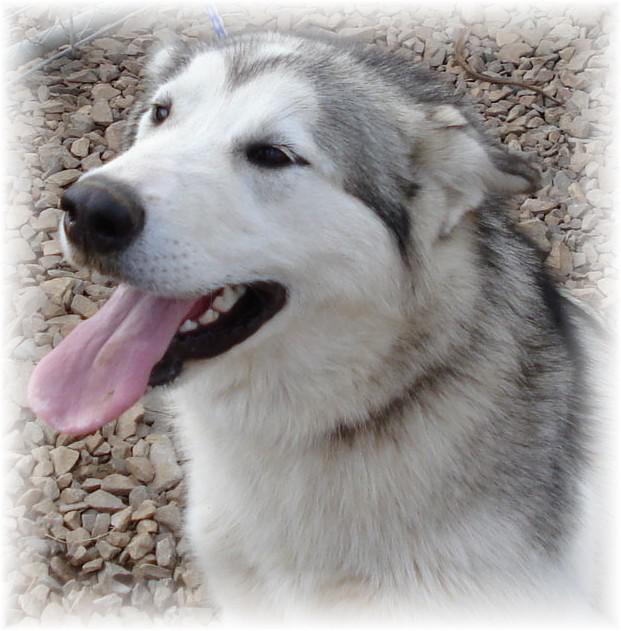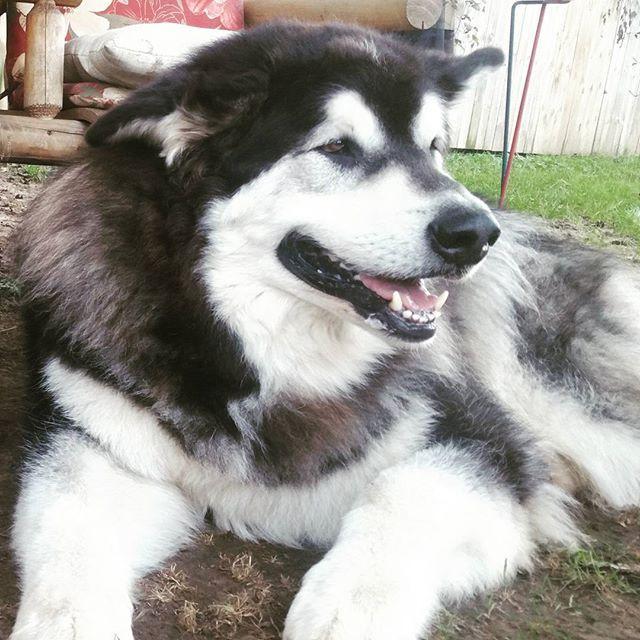The first image is the image on the left, the second image is the image on the right. For the images shown, is this caption "The right image contains at least two dogs." true? Answer yes or no. No. 